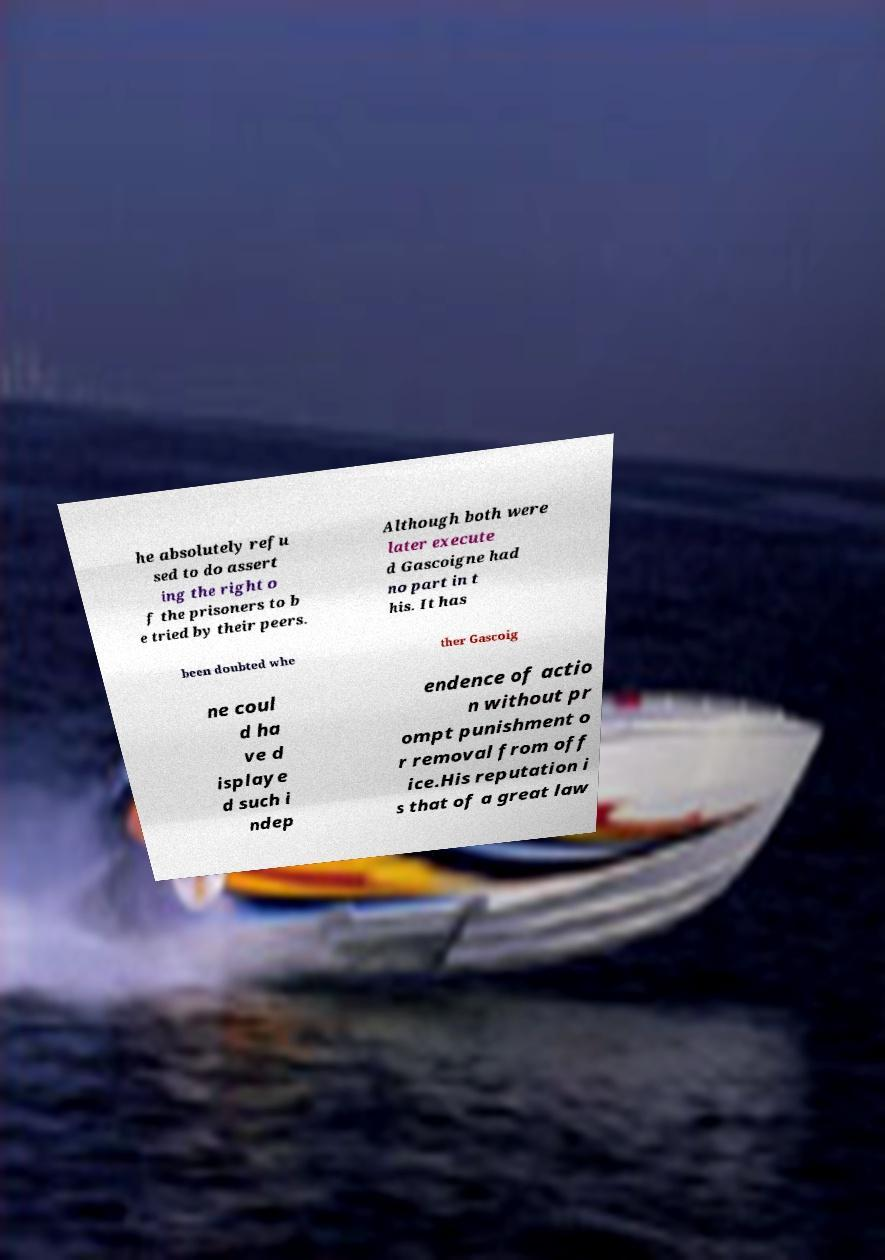Please identify and transcribe the text found in this image. he absolutely refu sed to do assert ing the right o f the prisoners to b e tried by their peers. Although both were later execute d Gascoigne had no part in t his. It has been doubted whe ther Gascoig ne coul d ha ve d isplaye d such i ndep endence of actio n without pr ompt punishment o r removal from off ice.His reputation i s that of a great law 